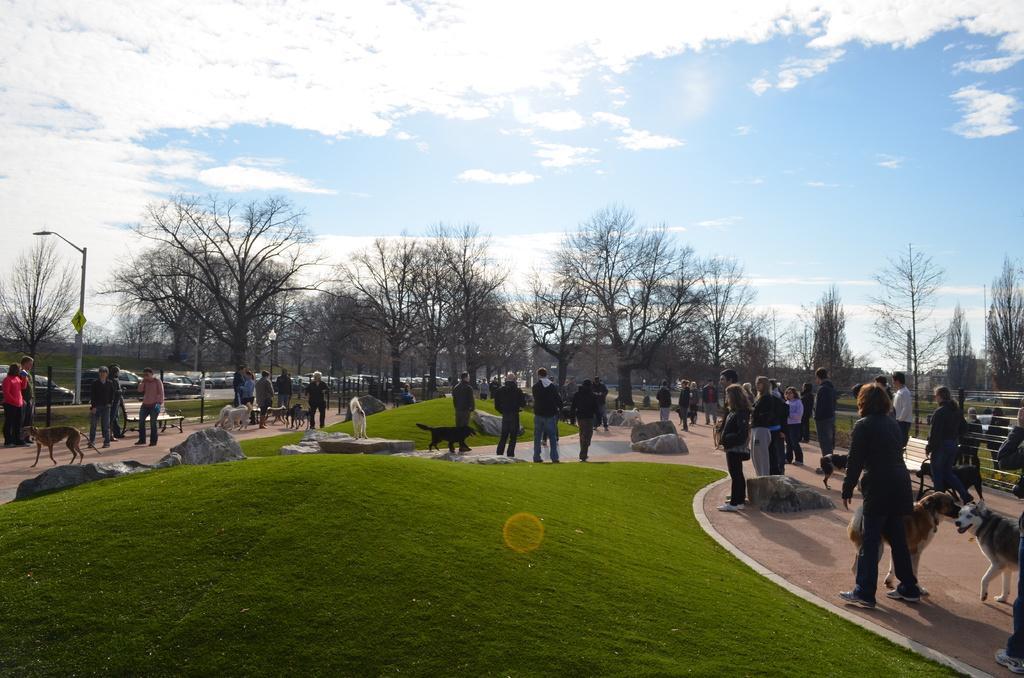Please provide a concise description of this image. In this image at the bottom there is grass, and there are a group of people and there are some dogs and some rocks chairs. In the background there are some vehicles, trees and some poles, boards and light. At the top of the image there is sky. 